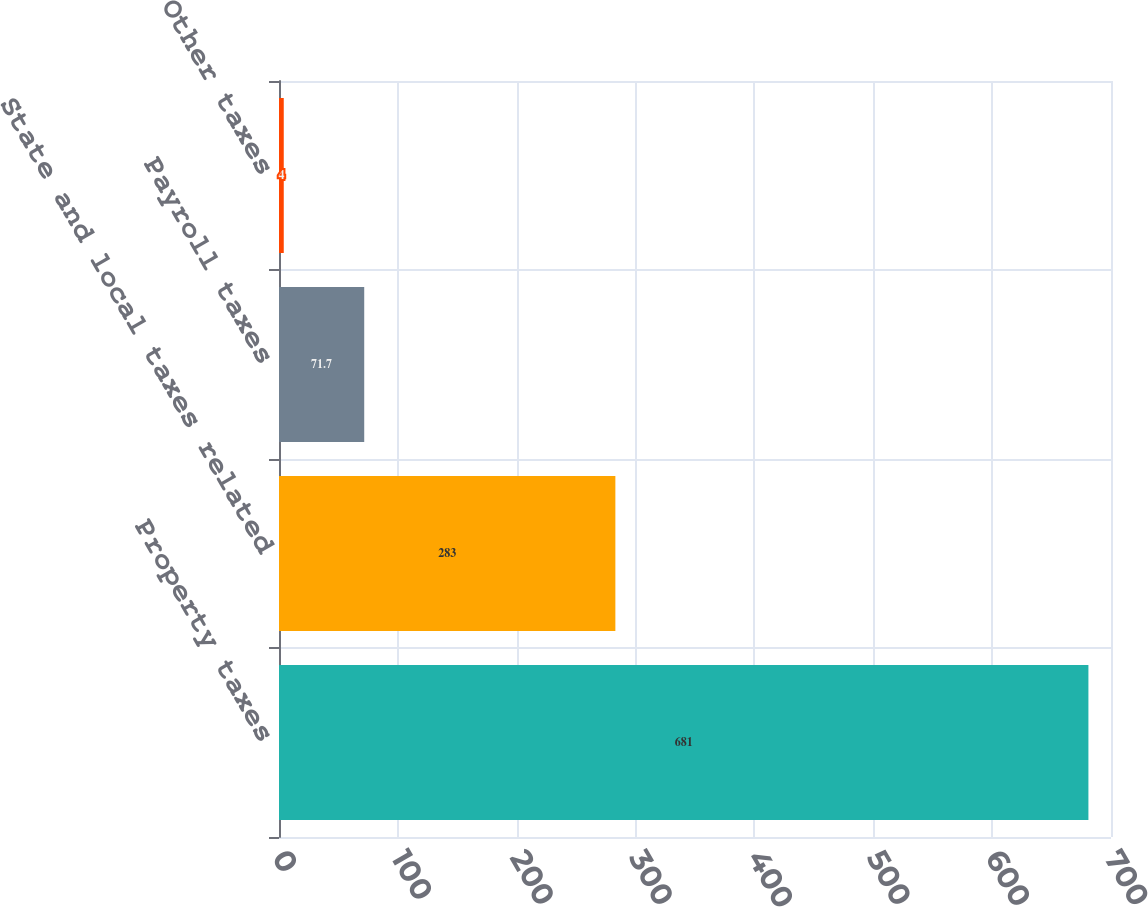<chart> <loc_0><loc_0><loc_500><loc_500><bar_chart><fcel>Property taxes<fcel>State and local taxes related<fcel>Payroll taxes<fcel>Other taxes<nl><fcel>681<fcel>283<fcel>71.7<fcel>4<nl></chart> 